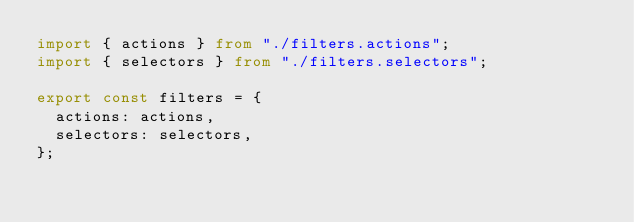Convert code to text. <code><loc_0><loc_0><loc_500><loc_500><_TypeScript_>import { actions } from "./filters.actions";
import { selectors } from "./filters.selectors";

export const filters = {
  actions: actions,
  selectors: selectors,
};
</code> 